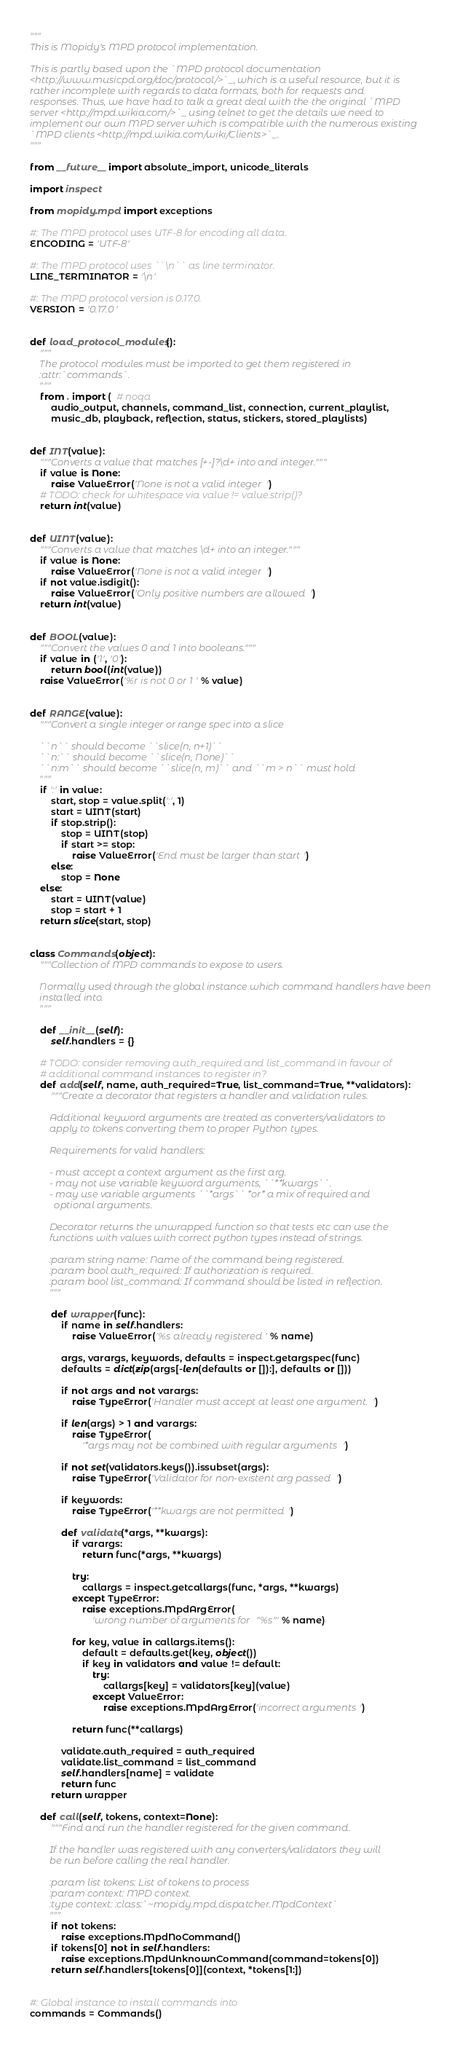<code> <loc_0><loc_0><loc_500><loc_500><_Python_>"""
This is Mopidy's MPD protocol implementation.

This is partly based upon the `MPD protocol documentation
<http://www.musicpd.org/doc/protocol/>`_, which is a useful resource, but it is
rather incomplete with regards to data formats, both for requests and
responses. Thus, we have had to talk a great deal with the the original `MPD
server <http://mpd.wikia.com/>`_ using telnet to get the details we need to
implement our own MPD server which is compatible with the numerous existing
`MPD clients <http://mpd.wikia.com/wiki/Clients>`_.
"""

from __future__ import absolute_import, unicode_literals

import inspect

from mopidy.mpd import exceptions

#: The MPD protocol uses UTF-8 for encoding all data.
ENCODING = 'UTF-8'

#: The MPD protocol uses ``\n`` as line terminator.
LINE_TERMINATOR = '\n'

#: The MPD protocol version is 0.17.0.
VERSION = '0.17.0'


def load_protocol_modules():
    """
    The protocol modules must be imported to get them registered in
    :attr:`commands`.
    """
    from . import (  # noqa
        audio_output, channels, command_list, connection, current_playlist,
        music_db, playback, reflection, status, stickers, stored_playlists)


def INT(value):
    """Converts a value that matches [+-]?\d+ into and integer."""
    if value is None:
        raise ValueError('None is not a valid integer')
    # TODO: check for whitespace via value != value.strip()?
    return int(value)


def UINT(value):
    """Converts a value that matches \d+ into an integer."""
    if value is None:
        raise ValueError('None is not a valid integer')
    if not value.isdigit():
        raise ValueError('Only positive numbers are allowed')
    return int(value)


def BOOL(value):
    """Convert the values 0 and 1 into booleans."""
    if value in ('1', '0'):
        return bool(int(value))
    raise ValueError('%r is not 0 or 1' % value)


def RANGE(value):
    """Convert a single integer or range spec into a slice

    ``n`` should become ``slice(n, n+1)``
    ``n:`` should become ``slice(n, None)``
    ``n:m`` should become ``slice(n, m)`` and ``m > n`` must hold
    """
    if ':' in value:
        start, stop = value.split(':', 1)
        start = UINT(start)
        if stop.strip():
            stop = UINT(stop)
            if start >= stop:
                raise ValueError('End must be larger than start')
        else:
            stop = None
    else:
        start = UINT(value)
        stop = start + 1
    return slice(start, stop)


class Commands(object):
    """Collection of MPD commands to expose to users.

    Normally used through the global instance which command handlers have been
    installed into.
    """

    def __init__(self):
        self.handlers = {}

    # TODO: consider removing auth_required and list_command in favour of
    # additional command instances to register in?
    def add(self, name, auth_required=True, list_command=True, **validators):
        """Create a decorator that registers a handler and validation rules.

        Additional keyword arguments are treated as converters/validators to
        apply to tokens converting them to proper Python types.

        Requirements for valid handlers:

        - must accept a context argument as the first arg.
        - may not use variable keyword arguments, ``**kwargs``.
        - may use variable arguments ``*args`` *or* a mix of required and
          optional arguments.

        Decorator returns the unwrapped function so that tests etc can use the
        functions with values with correct python types instead of strings.

        :param string name: Name of the command being registered.
        :param bool auth_required: If authorization is required.
        :param bool list_command: If command should be listed in reflection.
        """

        def wrapper(func):
            if name in self.handlers:
                raise ValueError('%s already registered' % name)

            args, varargs, keywords, defaults = inspect.getargspec(func)
            defaults = dict(zip(args[-len(defaults or []):], defaults or []))

            if not args and not varargs:
                raise TypeError('Handler must accept at least one argument.')

            if len(args) > 1 and varargs:
                raise TypeError(
                    '*args may not be combined with regular arguments')

            if not set(validators.keys()).issubset(args):
                raise TypeError('Validator for non-existent arg passed')

            if keywords:
                raise TypeError('**kwargs are not permitted')

            def validate(*args, **kwargs):
                if varargs:
                    return func(*args, **kwargs)

                try:
                    callargs = inspect.getcallargs(func, *args, **kwargs)
                except TypeError:
                    raise exceptions.MpdArgError(
                        'wrong number of arguments for "%s"' % name)

                for key, value in callargs.items():
                    default = defaults.get(key, object())
                    if key in validators and value != default:
                        try:
                            callargs[key] = validators[key](value)
                        except ValueError:
                            raise exceptions.MpdArgError('incorrect arguments')

                return func(**callargs)

            validate.auth_required = auth_required
            validate.list_command = list_command
            self.handlers[name] = validate
            return func
        return wrapper

    def call(self, tokens, context=None):
        """Find and run the handler registered for the given command.

        If the handler was registered with any converters/validators they will
        be run before calling the real handler.

        :param list tokens: List of tokens to process
        :param context: MPD context.
        :type context: :class:`~mopidy.mpd.dispatcher.MpdContext`
        """
        if not tokens:
            raise exceptions.MpdNoCommand()
        if tokens[0] not in self.handlers:
            raise exceptions.MpdUnknownCommand(command=tokens[0])
        return self.handlers[tokens[0]](context, *tokens[1:])


#: Global instance to install commands into
commands = Commands()
</code> 